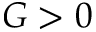Convert formula to latex. <formula><loc_0><loc_0><loc_500><loc_500>G > 0</formula> 